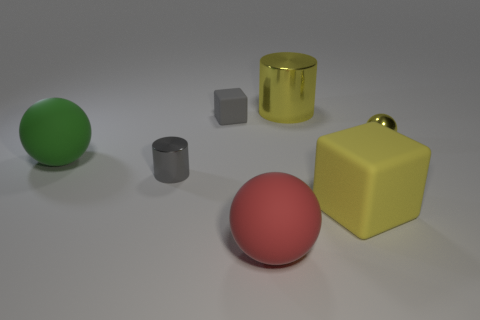Add 1 yellow cubes. How many objects exist? 8 Subtract all spheres. How many objects are left? 4 Subtract all big red matte things. Subtract all large green spheres. How many objects are left? 5 Add 4 large green balls. How many large green balls are left? 5 Add 2 small cyan matte objects. How many small cyan matte objects exist? 2 Subtract 0 brown spheres. How many objects are left? 7 